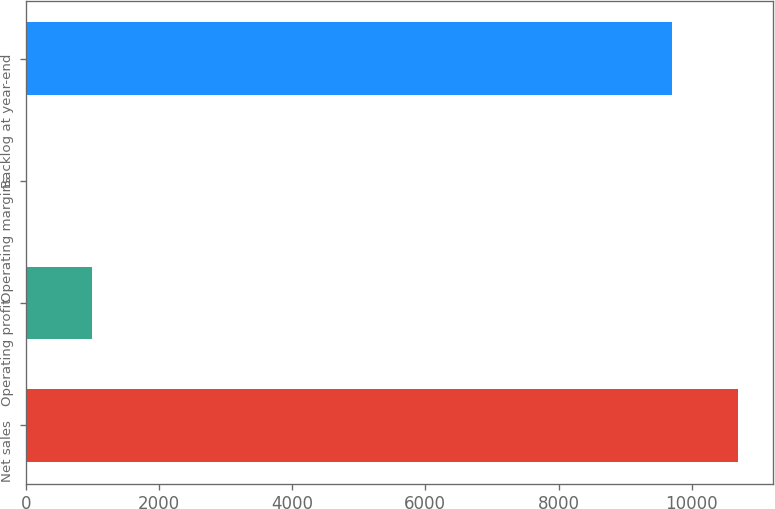<chart> <loc_0><loc_0><loc_500><loc_500><bar_chart><fcel>Net sales<fcel>Operating profit<fcel>Operating margins<fcel>Backlog at year-end<nl><fcel>10691.3<fcel>999.48<fcel>8.2<fcel>9700<nl></chart> 